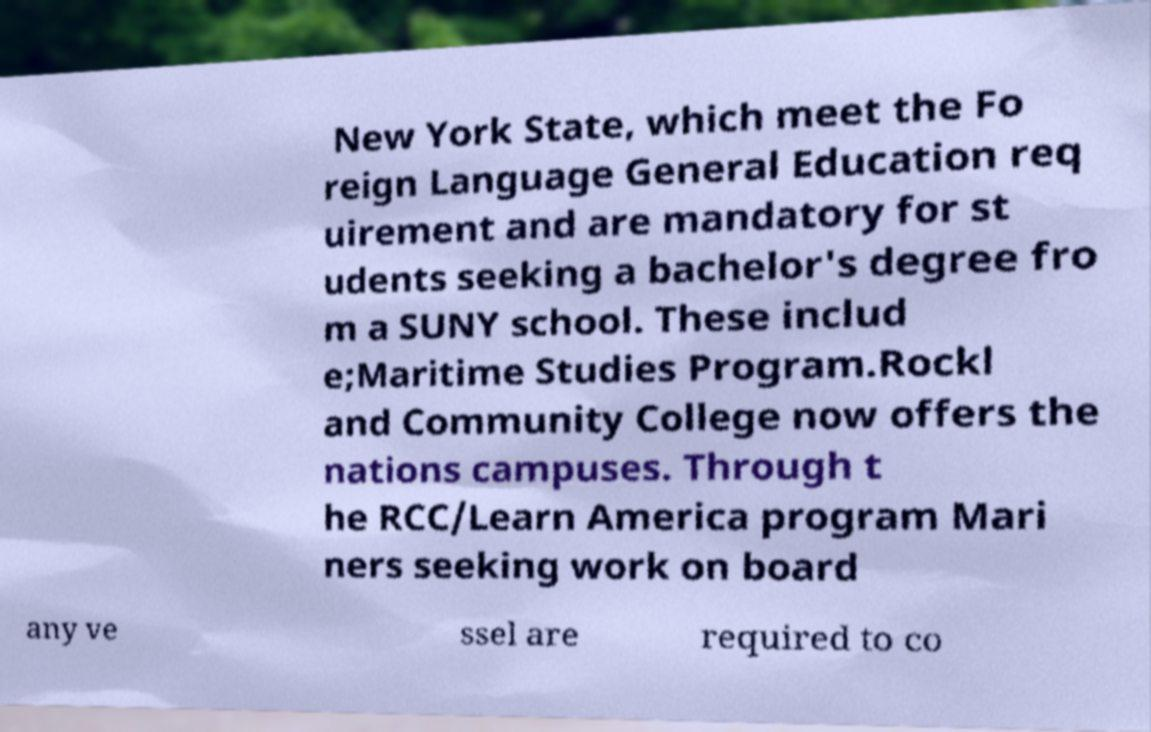I need the written content from this picture converted into text. Can you do that? New York State, which meet the Fo reign Language General Education req uirement and are mandatory for st udents seeking a bachelor's degree fro m a SUNY school. These includ e;Maritime Studies Program.Rockl and Community College now offers the nations campuses. Through t he RCC/Learn America program Mari ners seeking work on board any ve ssel are required to co 